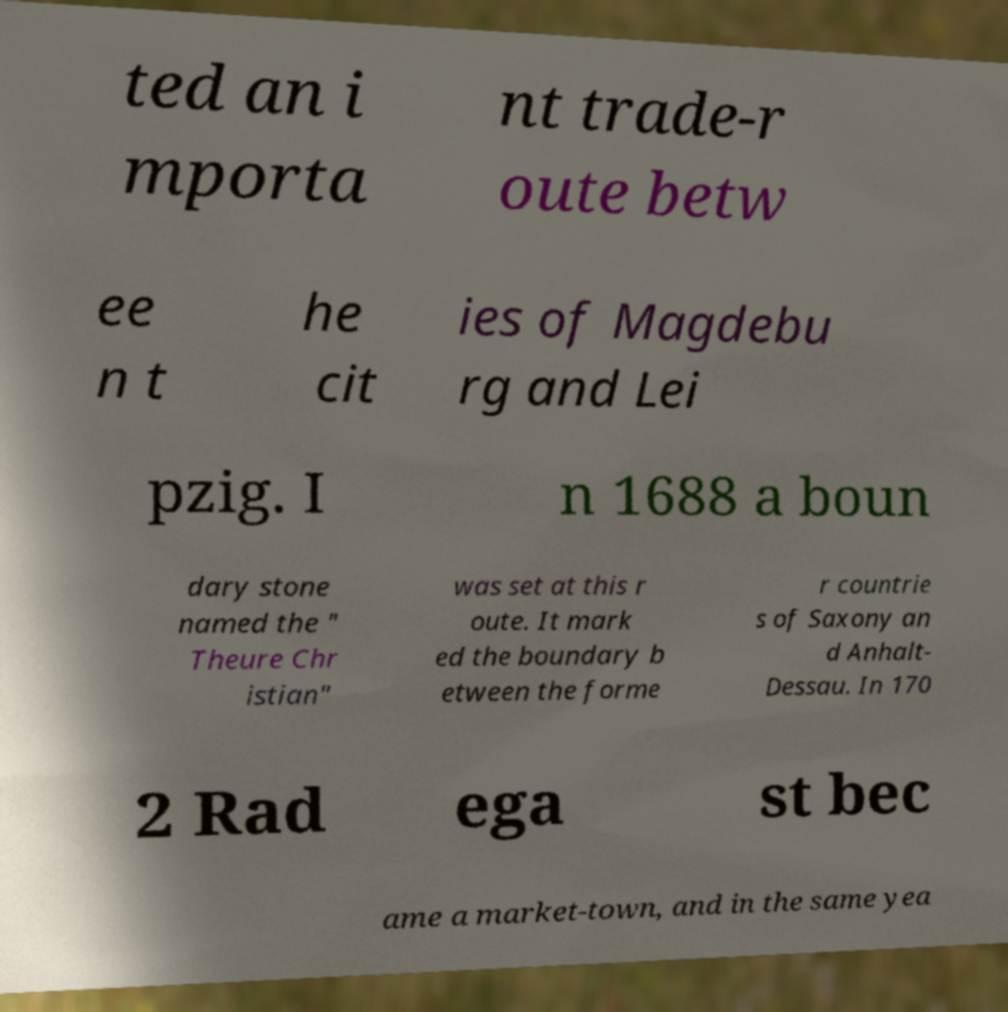I need the written content from this picture converted into text. Can you do that? ted an i mporta nt trade-r oute betw ee n t he cit ies of Magdebu rg and Lei pzig. I n 1688 a boun dary stone named the " Theure Chr istian" was set at this r oute. It mark ed the boundary b etween the forme r countrie s of Saxony an d Anhalt- Dessau. In 170 2 Rad ega st bec ame a market-town, and in the same yea 